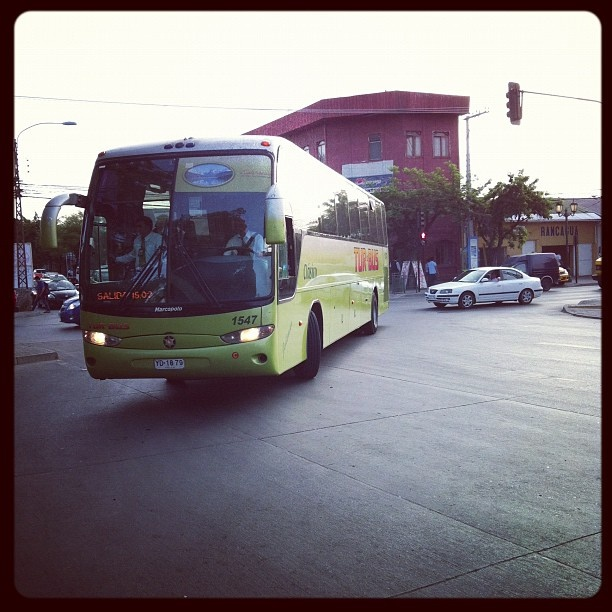Describe the objects in this image and their specific colors. I can see bus in black, gray, white, and darkgray tones, car in black, lavender, and darkgray tones, people in black, gray, and darkblue tones, car in black and purple tones, and people in black and gray tones in this image. 